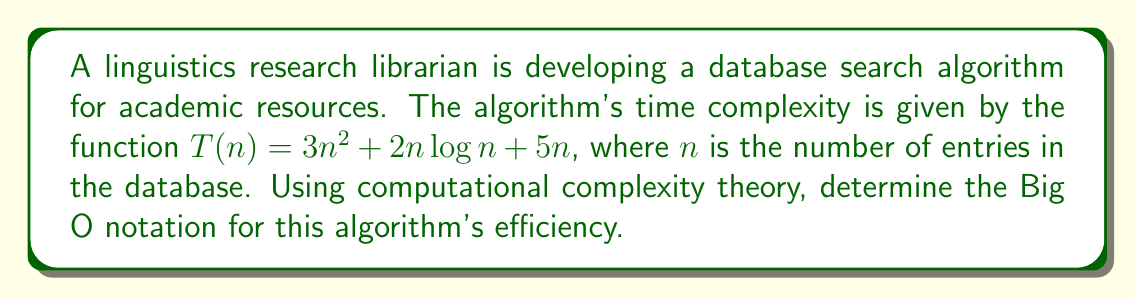Give your solution to this math problem. To determine the Big O notation for the given time complexity function, we need to identify the dominant term as $n$ approaches infinity. Let's analyze each term:

1. $3n^2$: This is a quadratic term.
2. $2n\log n$: This is a linearithmic term.
3. $5n$: This is a linear term.

Step 1: Compare the growth rates of these terms:
As $n$ increases, $n^2$ grows faster than $n\log n$, which grows faster than $n$.

Step 2: Identify the dominant term:
The dominant term is $3n^2$, as it grows the fastest for large values of $n$.

Step 3: Apply the definition of Big O notation:
Big O notation describes the upper bound of the growth rate, ignoring constant factors.

Step 4: Express the result in Big O notation:
Since the dominant term is $3n^2$, and we ignore the constant factor 3, the Big O notation for this algorithm's efficiency is $O(n^2)$.

This means that for sufficiently large input sizes, the algorithm's time complexity grows quadratically with respect to the input size.
Answer: $O(n^2)$ 